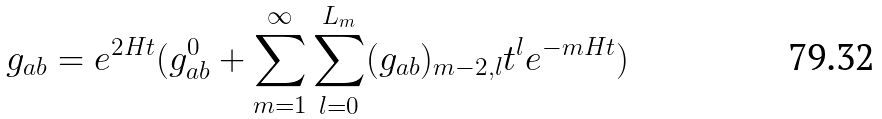Convert formula to latex. <formula><loc_0><loc_0><loc_500><loc_500>g _ { a b } = e ^ { 2 H t } ( g ^ { 0 } _ { a b } + \sum _ { m = 1 } ^ { \infty } \sum _ { l = 0 } ^ { L _ { m } } ( g _ { a b } ) _ { m - 2 , l } t ^ { l } e ^ { - m H t } )</formula> 